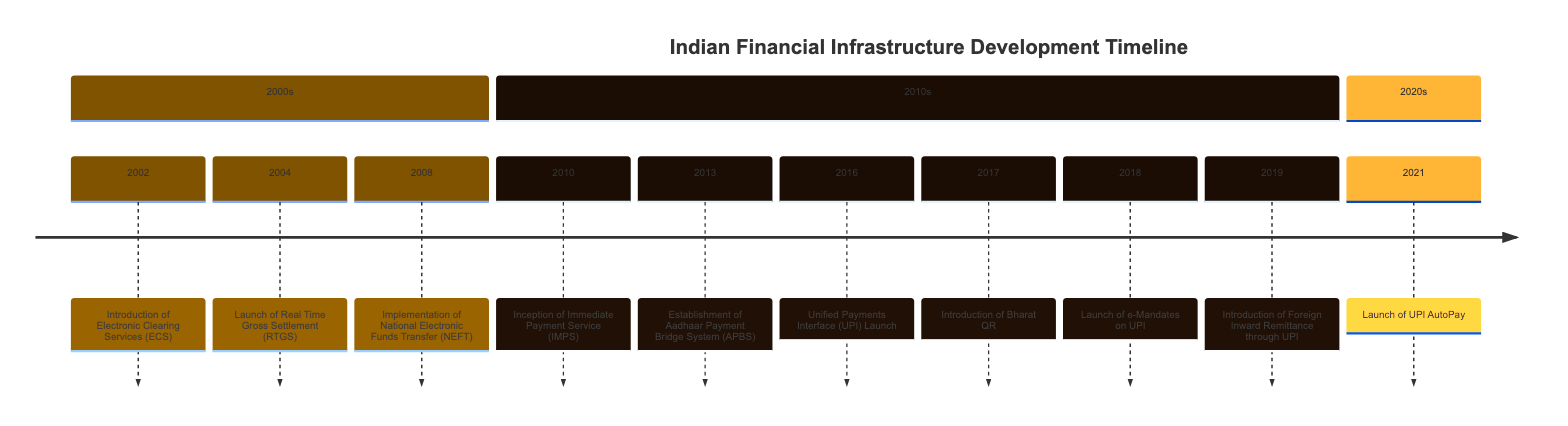What event was introduced in 2004? The timeline indicates that the "Launch of Real Time Gross Settlement (RTGS)" occurred in 2004.
Answer: Launch of Real Time Gross Settlement (RTGS) How many events are listed in the 2010s section? In the 2010s section, there are five events: IMPS, APBS, UPI Launch, Bharat QR, and e-Mandates on UPI are included, totaling five events.
Answer: 5 Which payment service was launched in 2008? According to the timeline, the "Implementation of National Electronic Funds Transfer (NEFT)" was launched in 2008.
Answer: Implementation of National Electronic Funds Transfer (NEFT) What significant digital payment system was launched in 2016? The timeline shows that the "Unified Payments Interface (UPI) Launch" was a significant event in 2016.
Answer: Unified Payments Interface (UPI) Launch What is the primary function of the Aadhaar Payment Bridge System established in 2013? The APBS was established to facilitate direct benefit transfers into beneficiaries' Aadhaar-linked bank accounts, mainly for government welfare schemes.
Answer: Direct benefit transfers Which event follows the launch of UPI on the timeline? After the UPI launch in 2016, the next event shown on the timeline is the "Introduction of Bharat QR" in 2017.
Answer: Introduction of Bharat QR How many years apart were the launch of UPI and the launch of UPI AutoPay? UPI was launched in 2016 and UPI AutoPay was launched in 2021, which means they are five years apart.
Answer: 5 What type of service is IMPS, launched in 2010? The "Inception of Immediate Payment Service (IMPS)" is indicated to be an instant interbank money transfer service launched in 2010.
Answer: Instant interbank money transfers What milestone in digital payments occurred in 2019? In 2019, the timeline shows the "Introduction of Foreign Inward Remittance through UPI" as the key milestone in digital payments.
Answer: Introduction of Foreign Inward Remittance through UPI What was the first entry in the timeline related to electronic payments? The first entry related to electronic payments in the timeline is the "Introduction of Electronic Clearing Services (ECS)" in 2002.
Answer: Introduction of Electronic Clearing Services (ECS) 